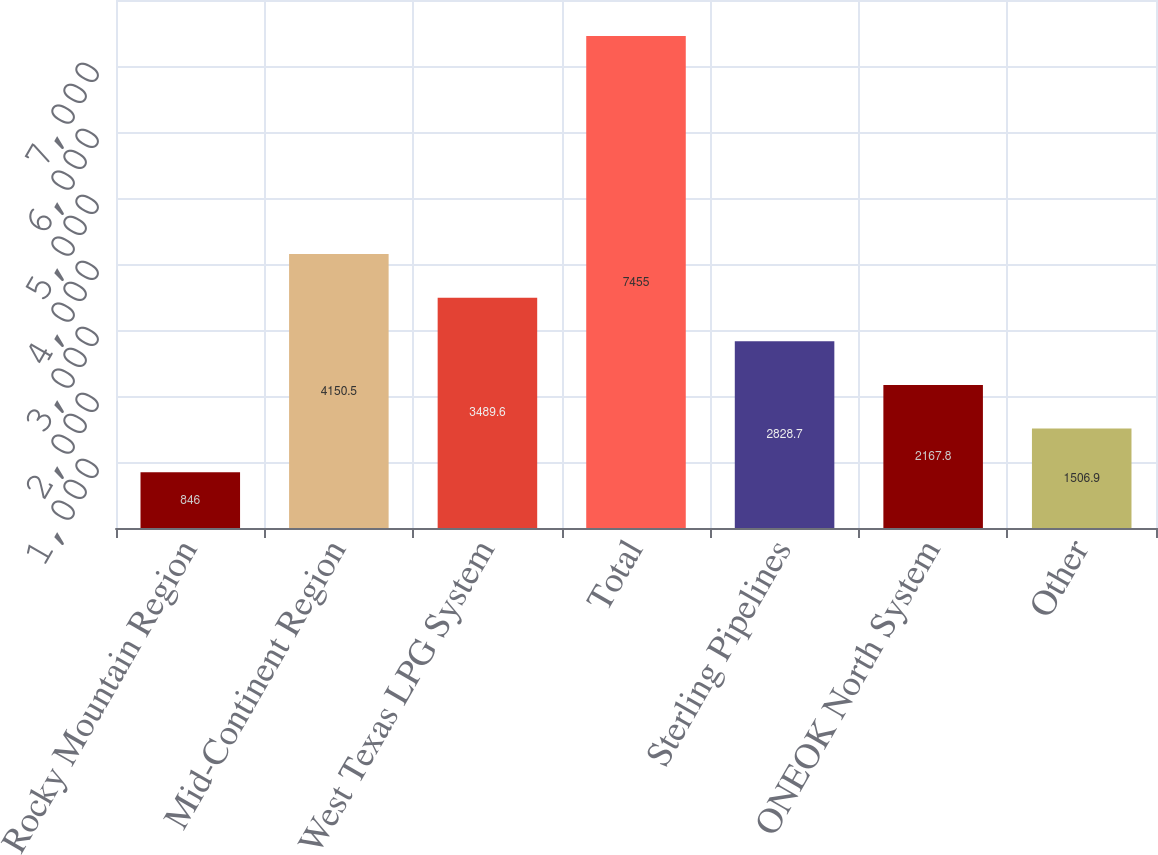Convert chart to OTSL. <chart><loc_0><loc_0><loc_500><loc_500><bar_chart><fcel>Rocky Mountain Region<fcel>Mid-Continent Region<fcel>West Texas LPG System<fcel>Total<fcel>Sterling Pipelines<fcel>ONEOK North System<fcel>Other<nl><fcel>846<fcel>4150.5<fcel>3489.6<fcel>7455<fcel>2828.7<fcel>2167.8<fcel>1506.9<nl></chart> 